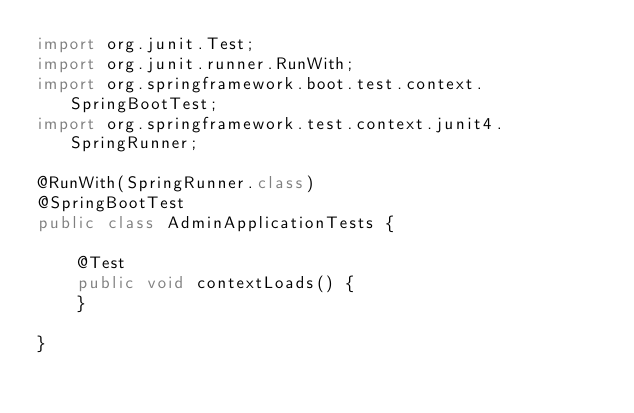Convert code to text. <code><loc_0><loc_0><loc_500><loc_500><_Java_>import org.junit.Test;
import org.junit.runner.RunWith;
import org.springframework.boot.test.context.SpringBootTest;
import org.springframework.test.context.junit4.SpringRunner;

@RunWith(SpringRunner.class)
@SpringBootTest
public class AdminApplicationTests {

	@Test
	public void contextLoads() {
	}

}
</code> 